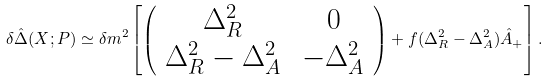<formula> <loc_0><loc_0><loc_500><loc_500>\delta \hat { \Delta } ( X ; P ) \simeq \delta m ^ { 2 } \left [ \left ( \begin{array} { c c } \Delta _ { R } ^ { 2 } & \, 0 \\ \Delta _ { R } ^ { 2 } - \Delta _ { A } ^ { 2 } & \, - \Delta _ { A } ^ { 2 } \end{array} \right ) + f ( \Delta _ { R } ^ { 2 } - \Delta _ { A } ^ { 2 } ) \hat { A } _ { + } \right ] .</formula> 